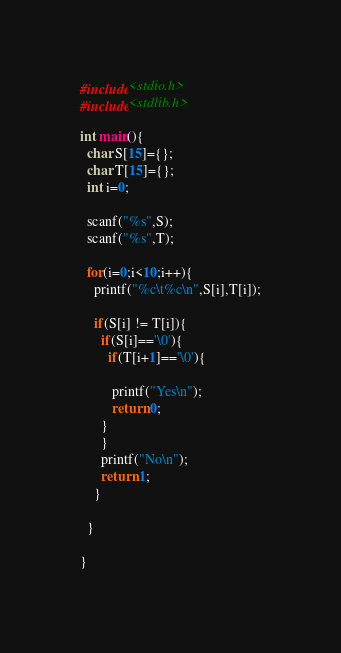Convert code to text. <code><loc_0><loc_0><loc_500><loc_500><_C_>#include<stdio.h>
#include<stdlib.h>

int main(){
  char S[15]={};
  char T[15]={};
  int i=0;
  
  scanf("%s",S);
  scanf("%s",T);
  
  for(i=0;i<10;i++){
    printf("%c\t%c\n",S[i],T[i]);
    
    if(S[i] != T[i]){
      if(S[i]=='\0'){
        if(T[i+1]=='\0'){
           
         printf("Yes\n");
         return 0;
      }
      }
      printf("No\n");
      return 1;
    }
    
  }

}</code> 